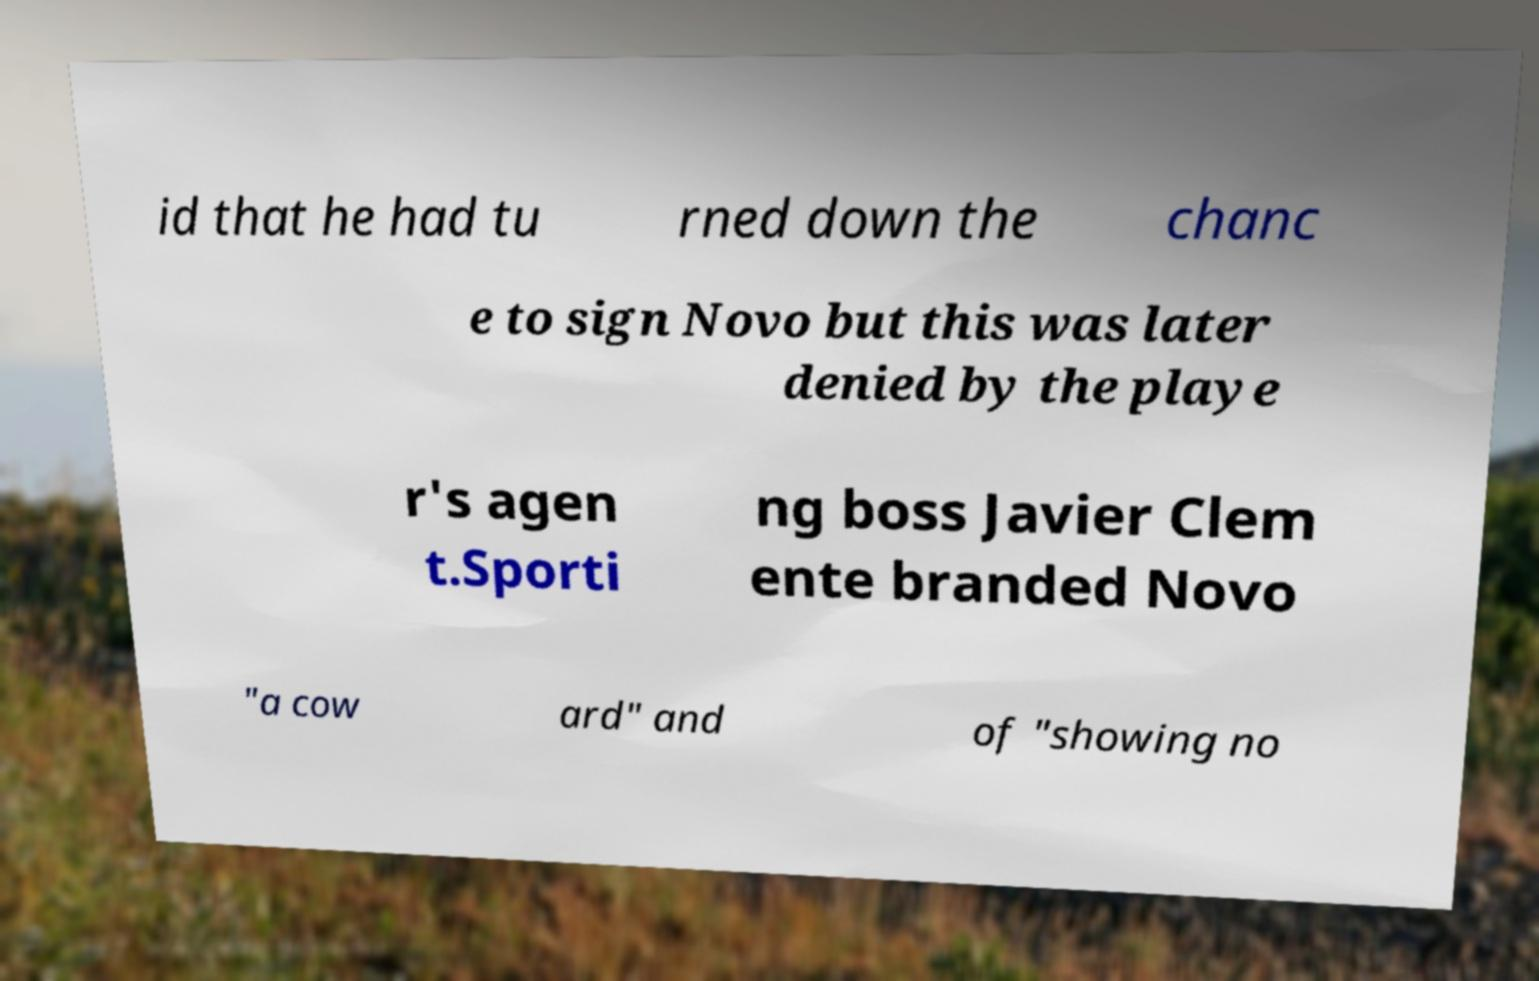What messages or text are displayed in this image? I need them in a readable, typed format. id that he had tu rned down the chanc e to sign Novo but this was later denied by the playe r's agen t.Sporti ng boss Javier Clem ente branded Novo "a cow ard" and of "showing no 